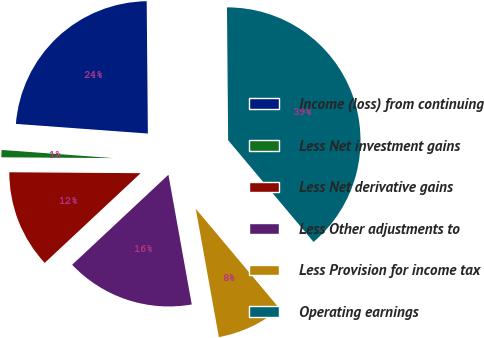Convert chart. <chart><loc_0><loc_0><loc_500><loc_500><pie_chart><fcel>Income (loss) from continuing<fcel>Less Net investment gains<fcel>Less Net derivative gains<fcel>Less Other adjustments to<fcel>Less Provision for income tax<fcel>Operating earnings<nl><fcel>23.7%<fcel>1.05%<fcel>12.08%<fcel>15.87%<fcel>8.28%<fcel>39.03%<nl></chart> 